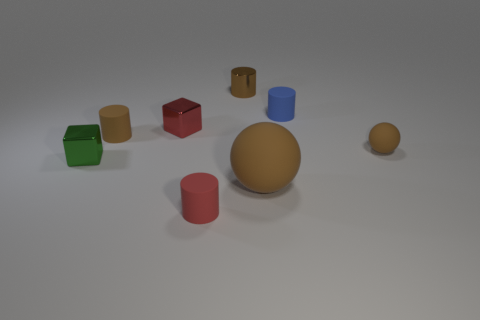Which objects in this image are closest to each other? The two cylindrical objects, one in red and the other in blue, appear to be closest to each other. 